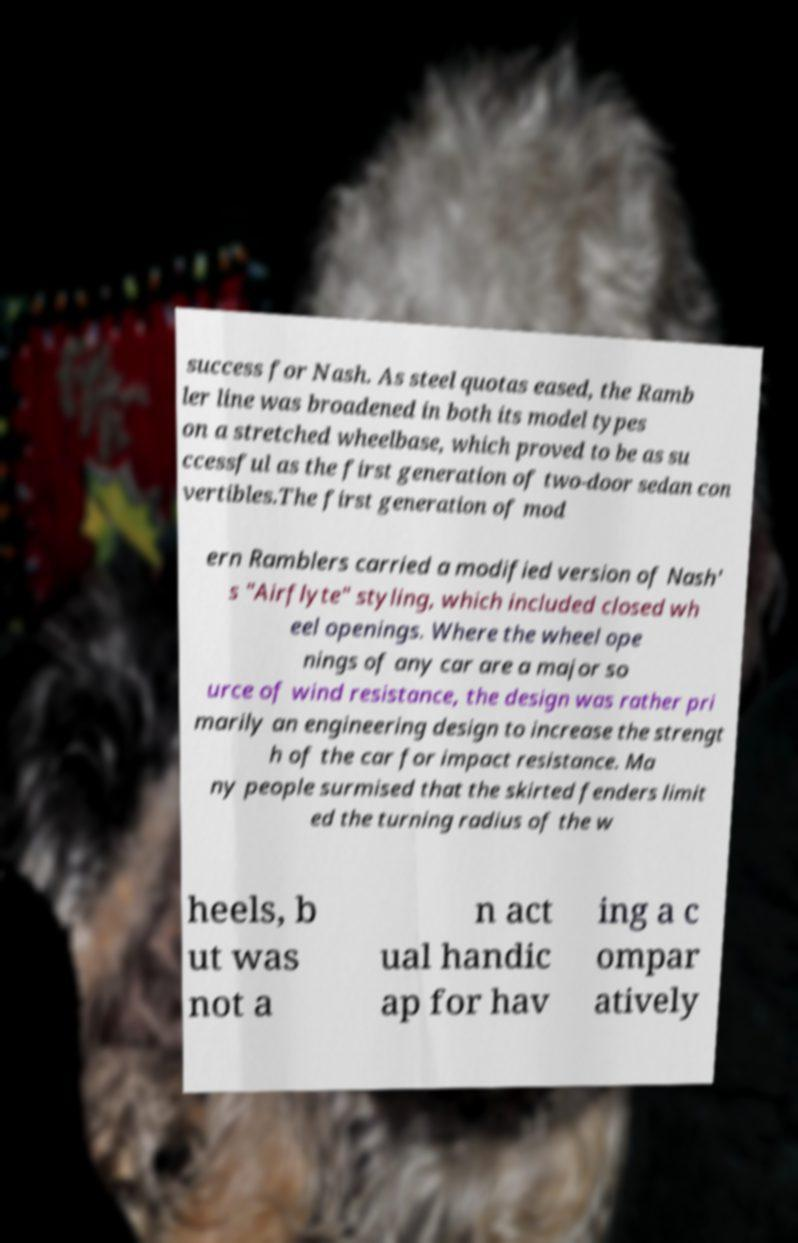Please read and relay the text visible in this image. What does it say? success for Nash. As steel quotas eased, the Ramb ler line was broadened in both its model types on a stretched wheelbase, which proved to be as su ccessful as the first generation of two-door sedan con vertibles.The first generation of mod ern Ramblers carried a modified version of Nash' s "Airflyte" styling, which included closed wh eel openings. Where the wheel ope nings of any car are a major so urce of wind resistance, the design was rather pri marily an engineering design to increase the strengt h of the car for impact resistance. Ma ny people surmised that the skirted fenders limit ed the turning radius of the w heels, b ut was not a n act ual handic ap for hav ing a c ompar atively 